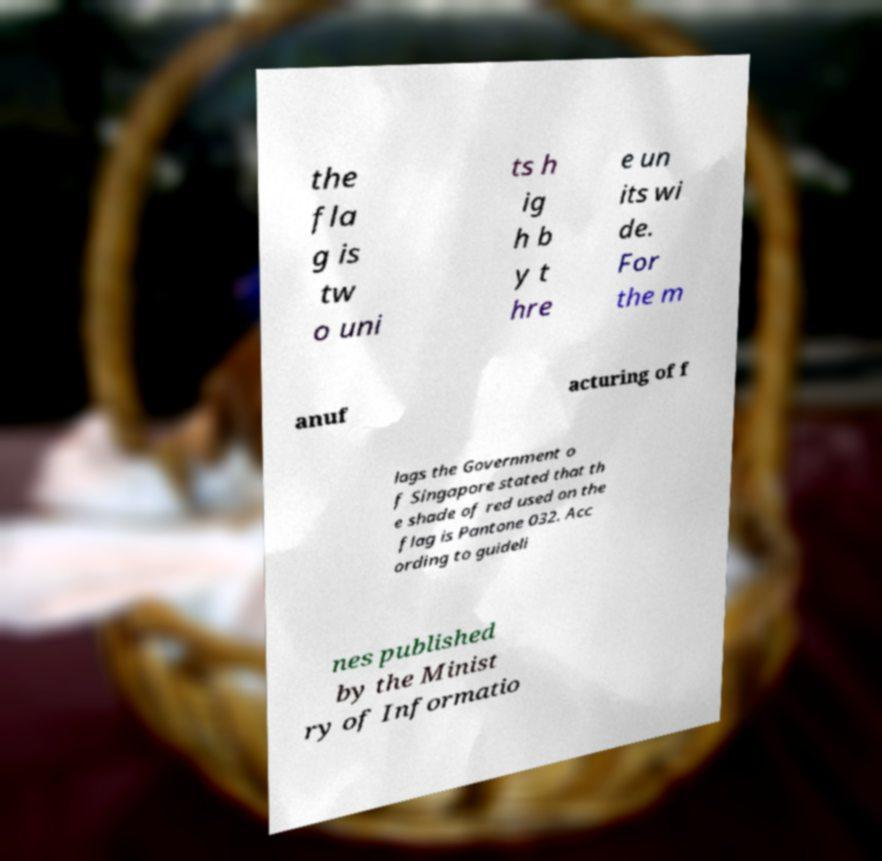Can you accurately transcribe the text from the provided image for me? the fla g is tw o uni ts h ig h b y t hre e un its wi de. For the m anuf acturing of f lags the Government o f Singapore stated that th e shade of red used on the flag is Pantone 032. Acc ording to guideli nes published by the Minist ry of Informatio 